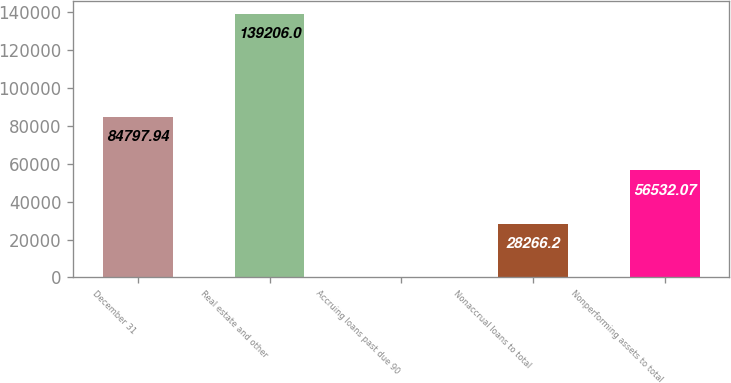<chart> <loc_0><loc_0><loc_500><loc_500><bar_chart><fcel>December 31<fcel>Real estate and other<fcel>Accruing loans past due 90<fcel>Nonaccrual loans to total<fcel>Nonperforming assets to total<nl><fcel>84797.9<fcel>139206<fcel>0.33<fcel>28266.2<fcel>56532.1<nl></chart> 